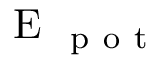Convert formula to latex. <formula><loc_0><loc_0><loc_500><loc_500>E _ { p o t }</formula> 